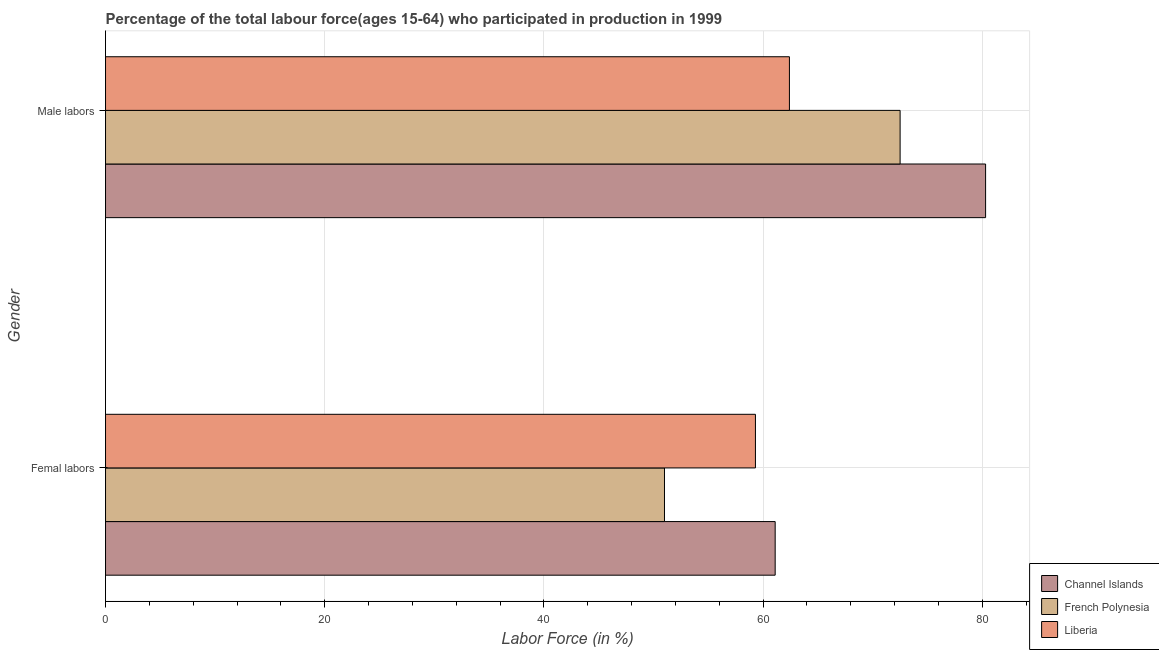How many different coloured bars are there?
Your answer should be very brief. 3. Are the number of bars on each tick of the Y-axis equal?
Your answer should be compact. Yes. How many bars are there on the 2nd tick from the top?
Ensure brevity in your answer.  3. How many bars are there on the 2nd tick from the bottom?
Offer a very short reply. 3. What is the label of the 1st group of bars from the top?
Ensure brevity in your answer.  Male labors. What is the percentage of female labor force in Liberia?
Keep it short and to the point. 59.3. Across all countries, what is the maximum percentage of male labour force?
Offer a terse response. 80.3. Across all countries, what is the minimum percentage of male labour force?
Ensure brevity in your answer.  62.4. In which country was the percentage of male labour force maximum?
Give a very brief answer. Channel Islands. In which country was the percentage of female labor force minimum?
Your answer should be compact. French Polynesia. What is the total percentage of male labour force in the graph?
Your response must be concise. 215.2. What is the difference between the percentage of male labour force in French Polynesia and that in Liberia?
Keep it short and to the point. 10.1. What is the difference between the percentage of female labor force in Liberia and the percentage of male labour force in Channel Islands?
Keep it short and to the point. -21. What is the average percentage of female labor force per country?
Make the answer very short. 57.13. What is the difference between the percentage of female labor force and percentage of male labour force in Channel Islands?
Your answer should be very brief. -19.2. In how many countries, is the percentage of male labour force greater than 44 %?
Give a very brief answer. 3. What is the ratio of the percentage of female labor force in French Polynesia to that in Liberia?
Your answer should be compact. 0.86. What does the 2nd bar from the top in Male labors represents?
Provide a succinct answer. French Polynesia. What does the 3rd bar from the bottom in Femal labors represents?
Provide a short and direct response. Liberia. How many bars are there?
Give a very brief answer. 6. How many countries are there in the graph?
Offer a very short reply. 3. What is the difference between two consecutive major ticks on the X-axis?
Keep it short and to the point. 20. Does the graph contain grids?
Your response must be concise. Yes. What is the title of the graph?
Your response must be concise. Percentage of the total labour force(ages 15-64) who participated in production in 1999. Does "Croatia" appear as one of the legend labels in the graph?
Give a very brief answer. No. What is the Labor Force (in %) in Channel Islands in Femal labors?
Your answer should be compact. 61.1. What is the Labor Force (in %) of French Polynesia in Femal labors?
Provide a succinct answer. 51. What is the Labor Force (in %) in Liberia in Femal labors?
Your response must be concise. 59.3. What is the Labor Force (in %) in Channel Islands in Male labors?
Ensure brevity in your answer.  80.3. What is the Labor Force (in %) of French Polynesia in Male labors?
Your answer should be very brief. 72.5. What is the Labor Force (in %) of Liberia in Male labors?
Keep it short and to the point. 62.4. Across all Gender, what is the maximum Labor Force (in %) of Channel Islands?
Provide a short and direct response. 80.3. Across all Gender, what is the maximum Labor Force (in %) in French Polynesia?
Provide a short and direct response. 72.5. Across all Gender, what is the maximum Labor Force (in %) in Liberia?
Your answer should be compact. 62.4. Across all Gender, what is the minimum Labor Force (in %) in Channel Islands?
Make the answer very short. 61.1. Across all Gender, what is the minimum Labor Force (in %) in French Polynesia?
Ensure brevity in your answer.  51. Across all Gender, what is the minimum Labor Force (in %) of Liberia?
Keep it short and to the point. 59.3. What is the total Labor Force (in %) of Channel Islands in the graph?
Give a very brief answer. 141.4. What is the total Labor Force (in %) in French Polynesia in the graph?
Your answer should be very brief. 123.5. What is the total Labor Force (in %) in Liberia in the graph?
Ensure brevity in your answer.  121.7. What is the difference between the Labor Force (in %) in Channel Islands in Femal labors and that in Male labors?
Provide a short and direct response. -19.2. What is the difference between the Labor Force (in %) in French Polynesia in Femal labors and that in Male labors?
Give a very brief answer. -21.5. What is the difference between the Labor Force (in %) of Liberia in Femal labors and that in Male labors?
Keep it short and to the point. -3.1. What is the difference between the Labor Force (in %) in Channel Islands in Femal labors and the Labor Force (in %) in French Polynesia in Male labors?
Make the answer very short. -11.4. What is the difference between the Labor Force (in %) of French Polynesia in Femal labors and the Labor Force (in %) of Liberia in Male labors?
Give a very brief answer. -11.4. What is the average Labor Force (in %) of Channel Islands per Gender?
Your answer should be compact. 70.7. What is the average Labor Force (in %) of French Polynesia per Gender?
Offer a terse response. 61.75. What is the average Labor Force (in %) of Liberia per Gender?
Keep it short and to the point. 60.85. What is the difference between the Labor Force (in %) in Channel Islands and Labor Force (in %) in French Polynesia in Femal labors?
Offer a very short reply. 10.1. What is the difference between the Labor Force (in %) in French Polynesia and Labor Force (in %) in Liberia in Femal labors?
Provide a succinct answer. -8.3. What is the difference between the Labor Force (in %) of Channel Islands and Labor Force (in %) of French Polynesia in Male labors?
Your response must be concise. 7.8. What is the difference between the Labor Force (in %) in Channel Islands and Labor Force (in %) in Liberia in Male labors?
Keep it short and to the point. 17.9. What is the ratio of the Labor Force (in %) of Channel Islands in Femal labors to that in Male labors?
Provide a short and direct response. 0.76. What is the ratio of the Labor Force (in %) in French Polynesia in Femal labors to that in Male labors?
Keep it short and to the point. 0.7. What is the ratio of the Labor Force (in %) of Liberia in Femal labors to that in Male labors?
Your answer should be compact. 0.95. What is the difference between the highest and the second highest Labor Force (in %) of French Polynesia?
Give a very brief answer. 21.5. What is the difference between the highest and the lowest Labor Force (in %) in Channel Islands?
Make the answer very short. 19.2. What is the difference between the highest and the lowest Labor Force (in %) of French Polynesia?
Give a very brief answer. 21.5. What is the difference between the highest and the lowest Labor Force (in %) of Liberia?
Offer a very short reply. 3.1. 